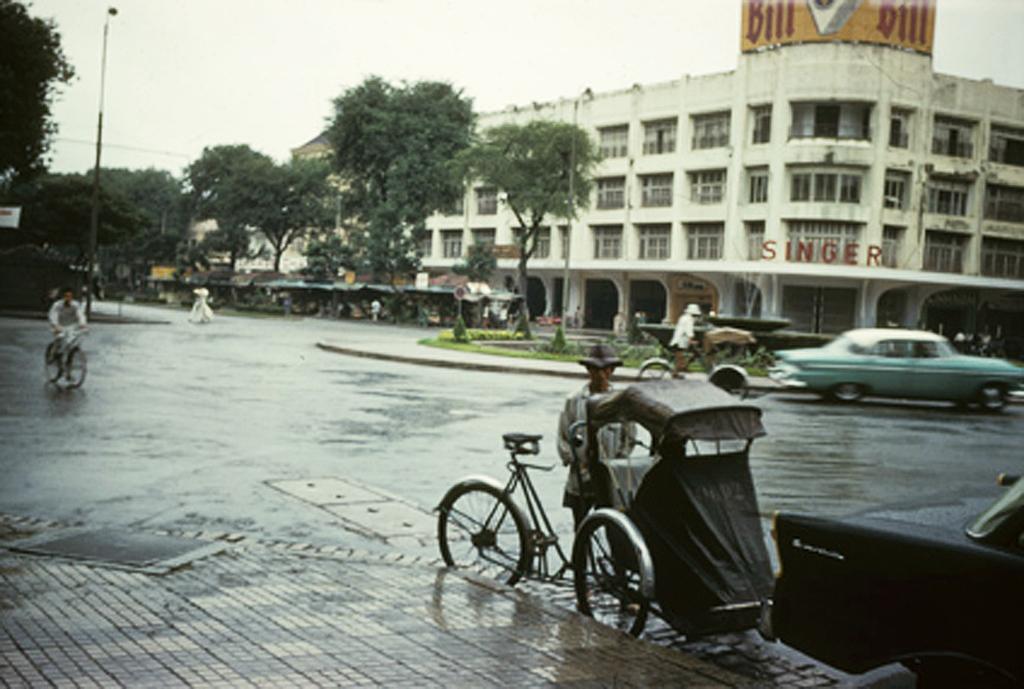Please provide a concise description of this image. In this image we can see buildings, trees, stalls on the road, persons riding bicycle, motor vehicles on the road, fountain, name board, street poles, street lights and sky. 